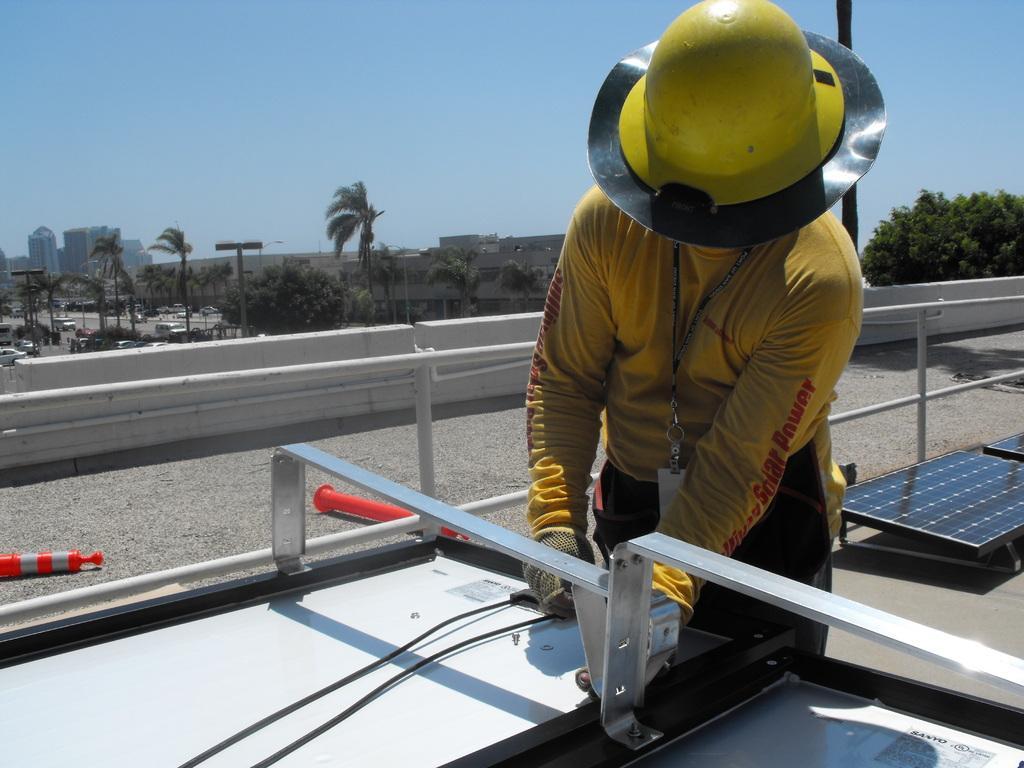Describe this image in one or two sentences. In this image there is a person wearing a cap. He is holding a object in his hand. There are wires. There is a metal railing. There are safety poles. In the background of the image there are buildings, trees, cars on the road. To the right side of the image there are solar panels. 